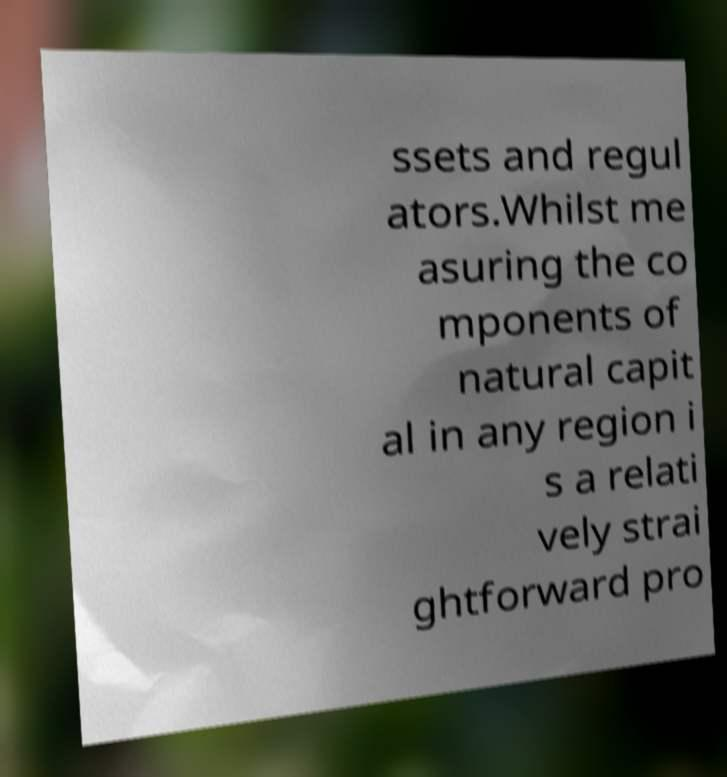There's text embedded in this image that I need extracted. Can you transcribe it verbatim? ssets and regul ators.Whilst me asuring the co mponents of natural capit al in any region i s a relati vely strai ghtforward pro 